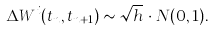<formula> <loc_0><loc_0><loc_500><loc_500>\Delta W ^ { i } ( t _ { n } , t _ { n + 1 } ) \sim \sqrt { h } \, \cdot N ( 0 , 1 ) .</formula> 